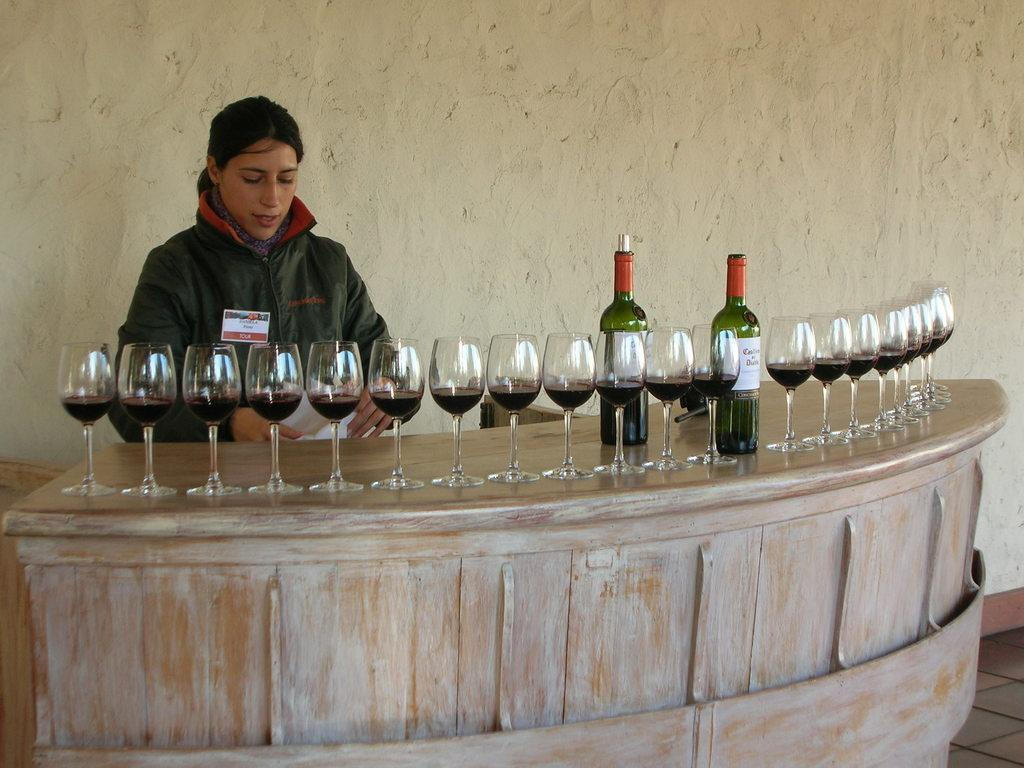Who is the main subject in the image? There is a woman in the image. What is the woman doing in the image? The woman is standing in front of a table. What objects are on the table in the image? There are glasses and two glass bottles on the table. What type of glue is being used to hold the woman's stomach in the image? There is no glue or reference to the woman's stomach in the image. 